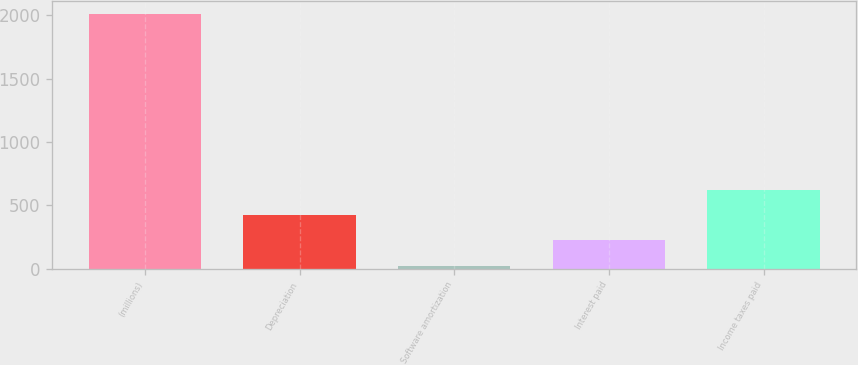<chart> <loc_0><loc_0><loc_500><loc_500><bar_chart><fcel>(millions)<fcel>Depreciation<fcel>Software amortization<fcel>Interest paid<fcel>Income taxes paid<nl><fcel>2011<fcel>421.72<fcel>24.4<fcel>223.06<fcel>620.38<nl></chart> 